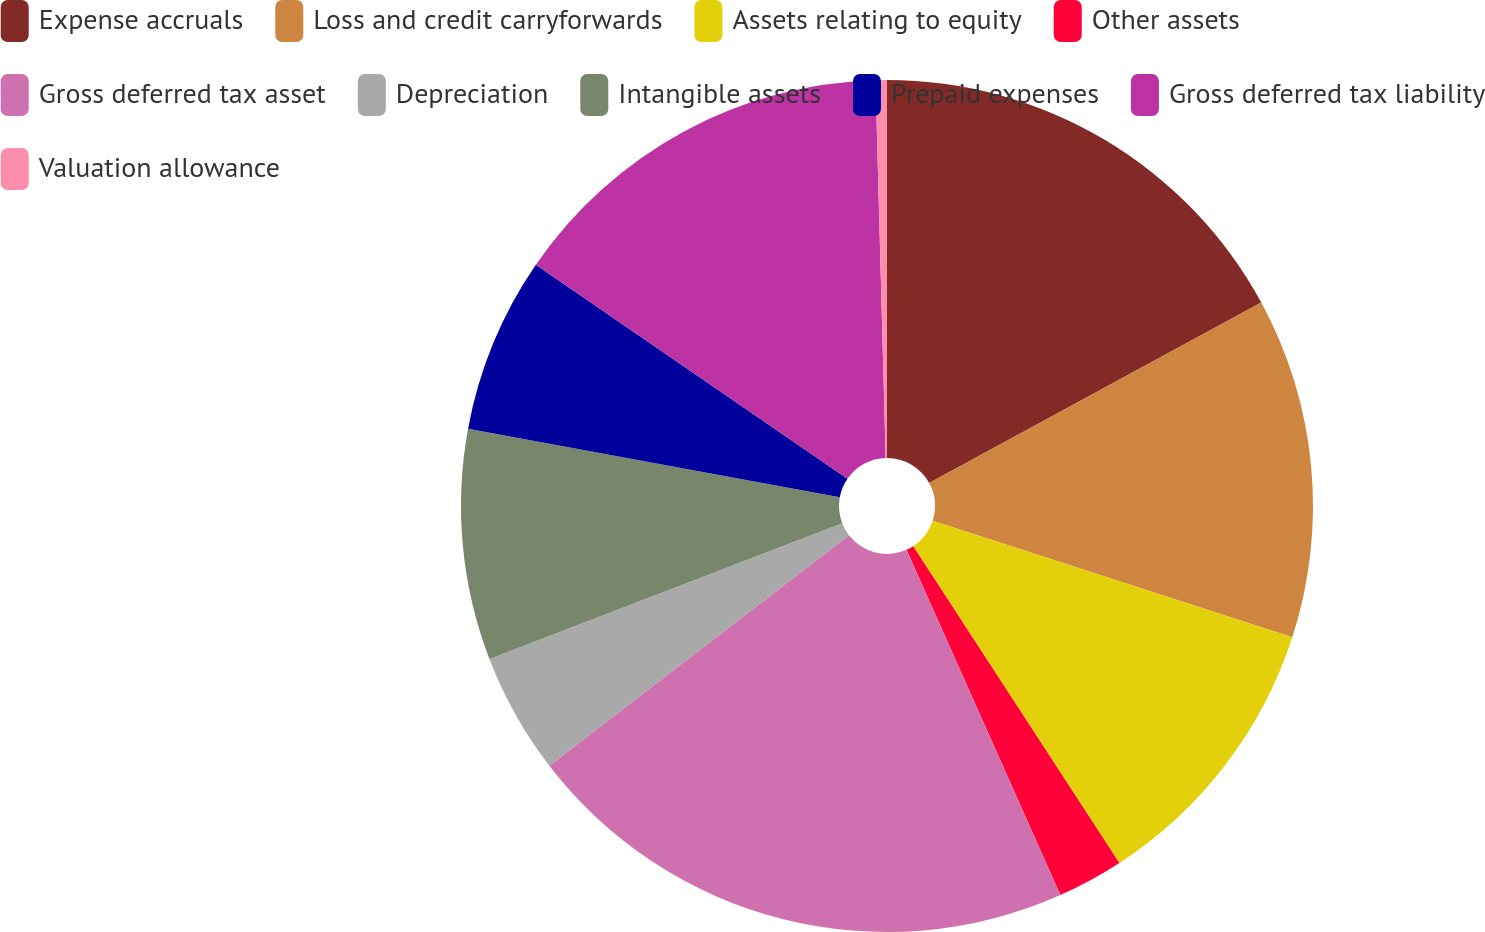Convert chart. <chart><loc_0><loc_0><loc_500><loc_500><pie_chart><fcel>Expense accruals<fcel>Loss and credit carryforwards<fcel>Assets relating to equity<fcel>Other assets<fcel>Gross deferred tax asset<fcel>Depreciation<fcel>Intangible assets<fcel>Prepaid expenses<fcel>Gross deferred tax liability<fcel>Valuation allowance<nl><fcel>17.07%<fcel>12.91%<fcel>10.83%<fcel>2.51%<fcel>21.23%<fcel>4.59%<fcel>8.75%<fcel>6.67%<fcel>14.99%<fcel>0.43%<nl></chart> 